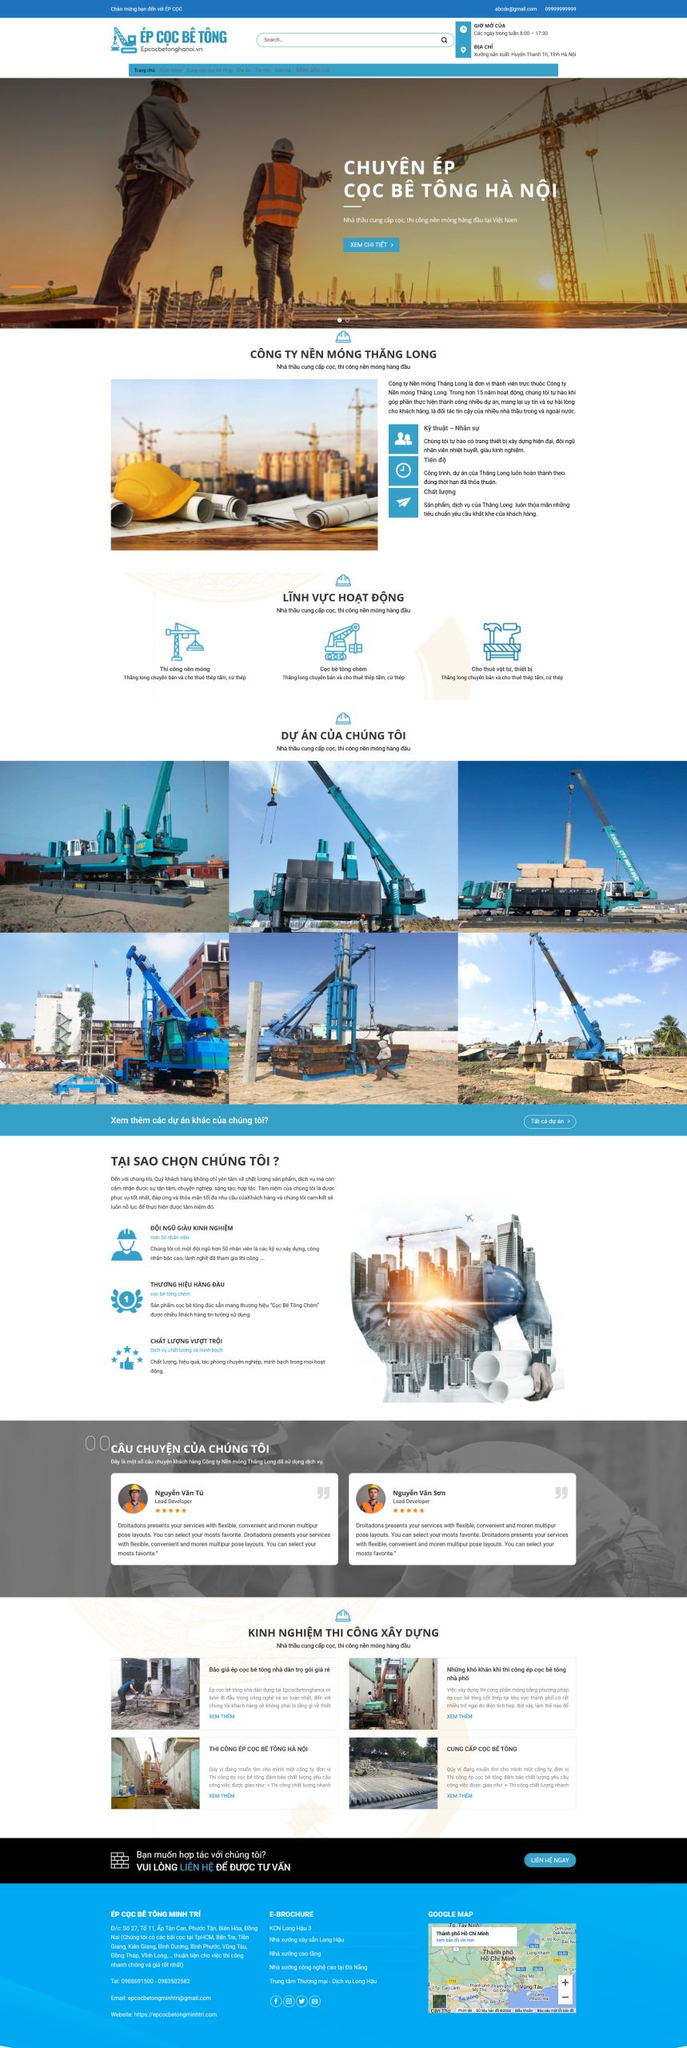Liệt kê 5 ngành nghề, lĩnh vực phù hợp với website này, phân cách các màu sắc bằng dấu phẩy. Chỉ trả về kết quả, phân cách bằng dấy phẩy
 xây dựng, kiến trúc, thi công nền móng, ép cọc bê tông, cung cấp vật liệu xây dựng 